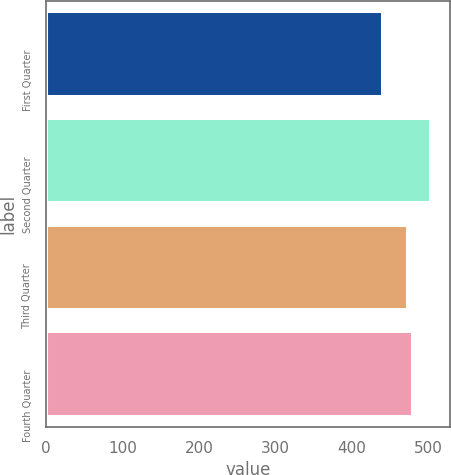Convert chart. <chart><loc_0><loc_0><loc_500><loc_500><bar_chart><fcel>First Quarter<fcel>Second Quarter<fcel>Third Quarter<fcel>Fourth Quarter<nl><fcel>440<fcel>503.01<fcel>472.48<fcel>479.5<nl></chart> 